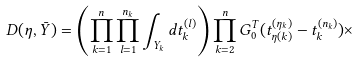Convert formula to latex. <formula><loc_0><loc_0><loc_500><loc_500>\ D ( \eta , \bar { Y } ) = \left ( \prod _ { k = 1 } ^ { n } \prod _ { l = 1 } ^ { n _ { k } } \int _ { Y _ { k } } d t ^ { ( l ) } _ { k } \right ) \prod _ { k = 2 } ^ { n } G _ { 0 } ^ { T } ( t _ { \eta ( k ) } ^ { ( \eta _ { k } ) } - t _ { k } ^ { ( n _ { k } ) } ) \times</formula> 